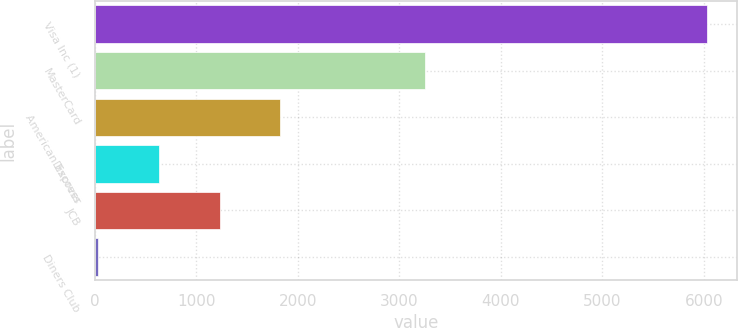<chart> <loc_0><loc_0><loc_500><loc_500><bar_chart><fcel>Visa Inc (1)<fcel>MasterCard<fcel>American Express<fcel>Discover<fcel>JCB<fcel>Diners Club<nl><fcel>6029<fcel>3249<fcel>1829<fcel>629<fcel>1229<fcel>29<nl></chart> 